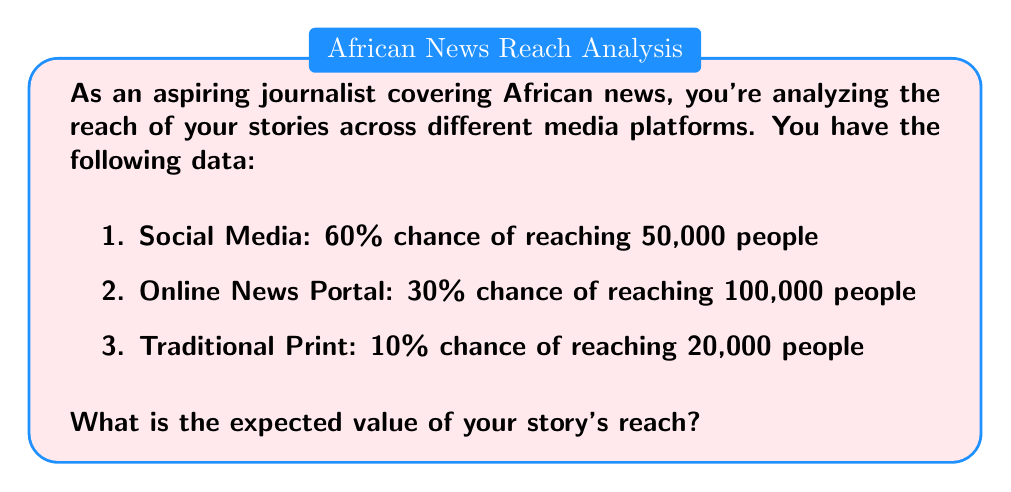Can you answer this question? To solve this problem, we need to calculate the expected value of the story's reach across all platforms. The expected value is the sum of each outcome multiplied by its probability.

Let's break it down step-by-step:

1. Social Media:
   Probability = 60% = 0.6
   Reach = 50,000
   Expected Value = $0.6 \times 50,000 = 30,000$

2. Online News Portal:
   Probability = 30% = 0.3
   Reach = 100,000
   Expected Value = $0.3 \times 100,000 = 30,000$

3. Traditional Print:
   Probability = 10% = 0.1
   Reach = 20,000
   Expected Value = $0.1 \times 20,000 = 2,000$

Now, we sum up the expected values from all platforms:

$$ \text{Total Expected Value} = 30,000 + 30,000 + 2,000 = 62,000 $$

Therefore, the expected value of the story's reach is 62,000 people.
Answer: 62,000 people 